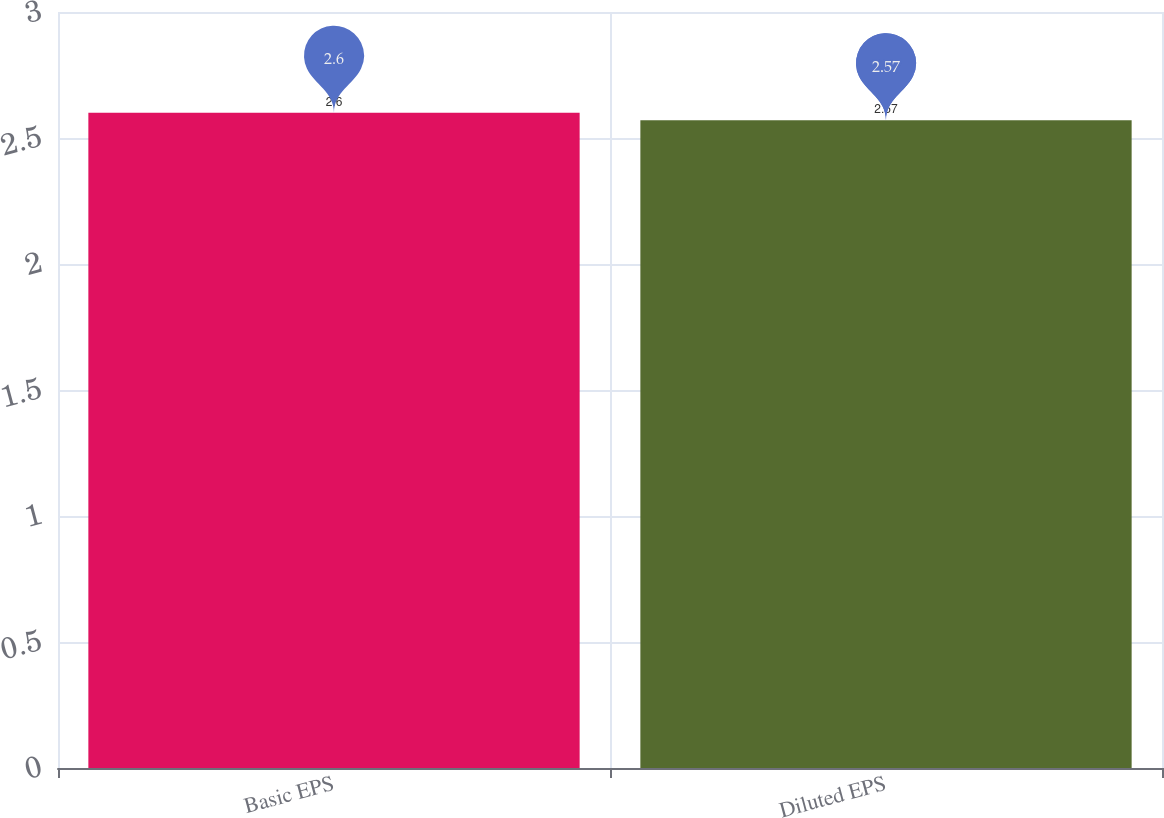Convert chart. <chart><loc_0><loc_0><loc_500><loc_500><bar_chart><fcel>Basic EPS<fcel>Diluted EPS<nl><fcel>2.6<fcel>2.57<nl></chart> 